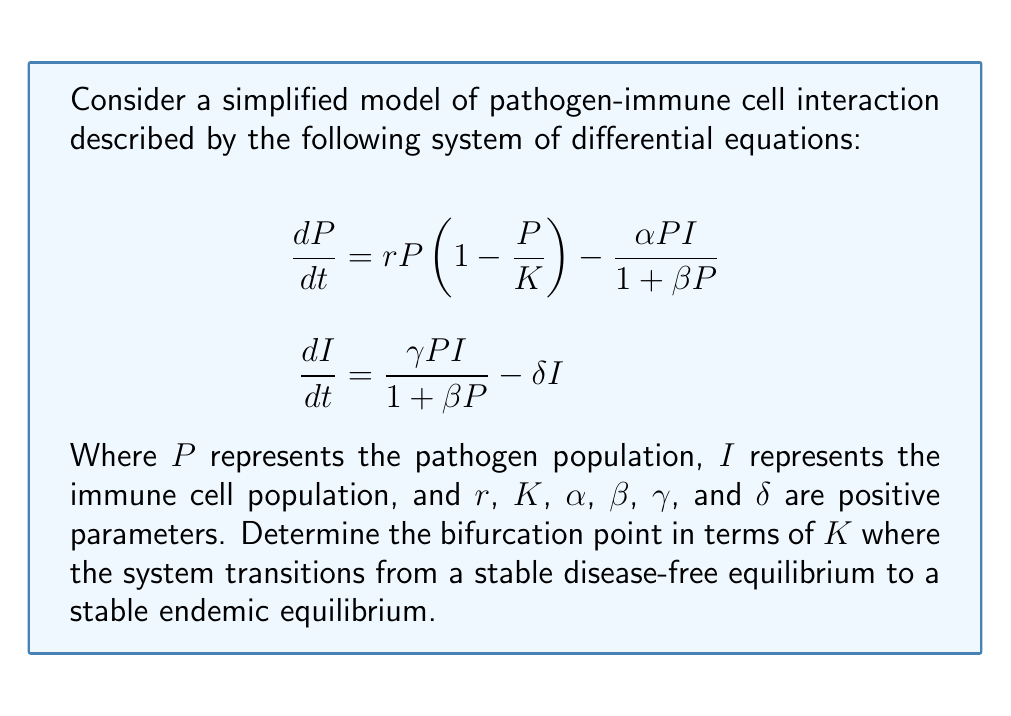What is the answer to this math problem? To solve this problem, we'll follow these steps:

1) First, we need to find the disease-free equilibrium (DFE). At this point, $P = 0$ and $I = 0$.

2) Next, we'll analyze the stability of the DFE by linearizing the system around this point and examining the eigenvalues of the resulting Jacobian matrix.

3) The Jacobian matrix at the DFE is:

   $$J_{DFE} = \begin{bmatrix}
   r & 0 \\
   0 & -\delta
   \end{bmatrix}$$

4) The eigenvalues of this matrix are $\lambda_1 = r$ and $\lambda_2 = -\delta$. For the DFE to be stable, we need both eigenvalues to be negative. Since $\delta > 0$, we only need to focus on $\lambda_1 = r$.

5) The DFE loses stability when $r$ changes from negative to positive. This occurs when $r = 0$.

6) Recalling the original equation for $\frac{dP}{dt}$, we can see that $r$ is actually $r\left(1 - \frac{P}{K}\right)$ when $I = 0$.

7) Setting this equal to zero:

   $$r\left(1 - \frac{P}{K}\right) = 0$$

8) Solving for $K$:

   $$K = P$$

9) At the bifurcation point, $P$ will be very close to zero. Therefore, the bifurcation occurs when $K$ approaches zero from the positive side.

Thus, the bifurcation point occurs at $K = 0^+$, where the system transitions from a stable disease-free equilibrium (when $K < 0$, which is biologically impossible) to a potentially stable endemic equilibrium (when $K > 0$).
Answer: $K = 0^+$ 